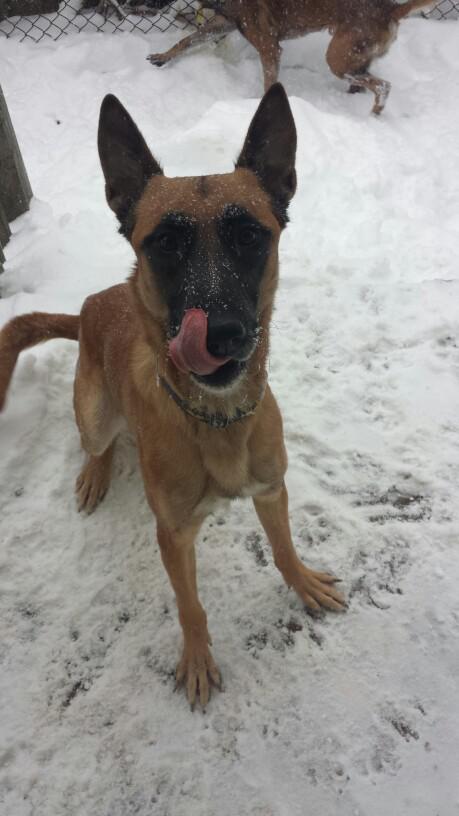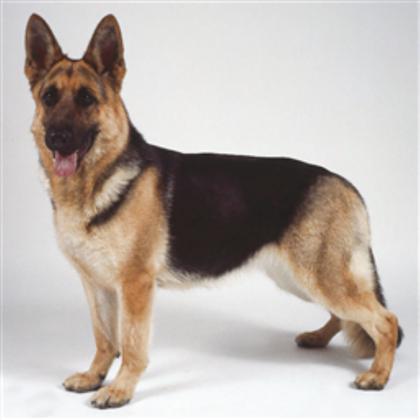The first image is the image on the left, the second image is the image on the right. Considering the images on both sides, is "An image contains a dog eating dog food from a bowl." valid? Answer yes or no. No. The first image is the image on the left, the second image is the image on the right. Given the left and right images, does the statement "One dog is eating and has its head near a round bowl of food, and the other dog figure is standing on all fours." hold true? Answer yes or no. No. 